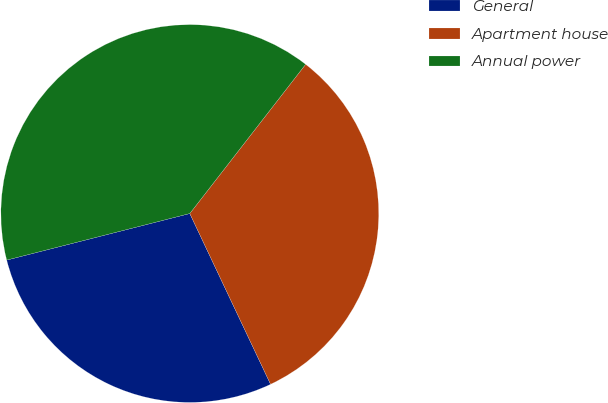Convert chart to OTSL. <chart><loc_0><loc_0><loc_500><loc_500><pie_chart><fcel>General<fcel>Apartment house<fcel>Annual power<nl><fcel>28.07%<fcel>32.46%<fcel>39.47%<nl></chart> 